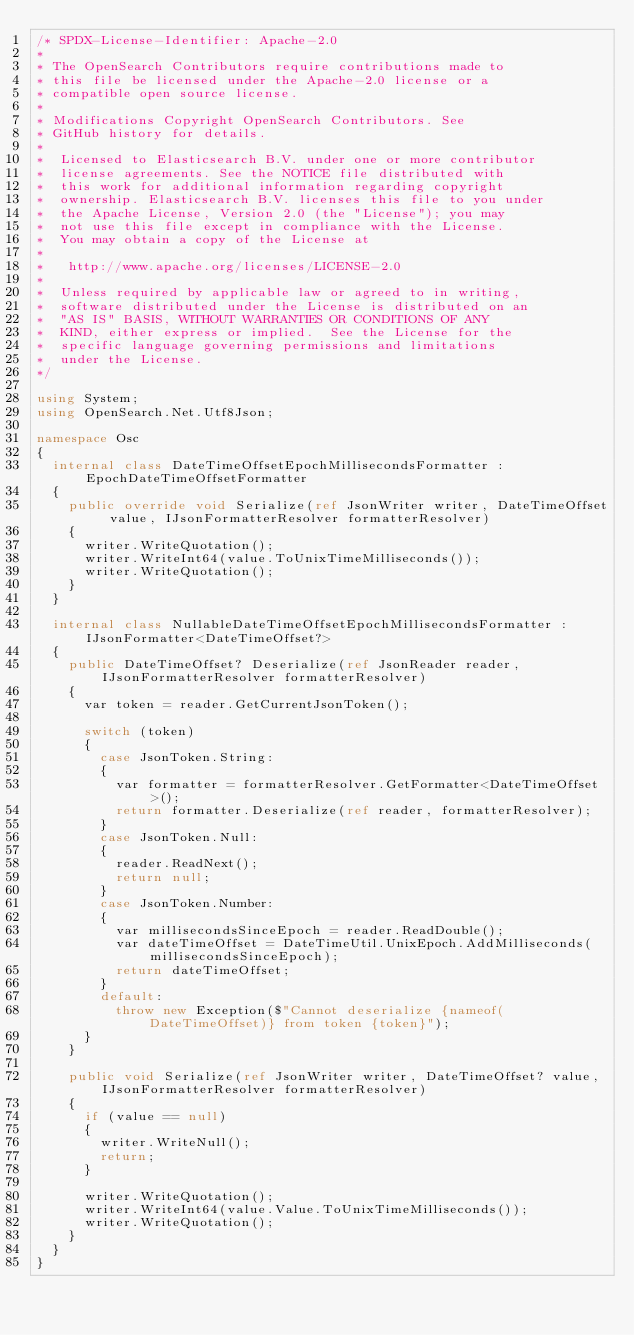Convert code to text. <code><loc_0><loc_0><loc_500><loc_500><_C#_>/* SPDX-License-Identifier: Apache-2.0
*
* The OpenSearch Contributors require contributions made to
* this file be licensed under the Apache-2.0 license or a
* compatible open source license.
*
* Modifications Copyright OpenSearch Contributors. See
* GitHub history for details.
*
*  Licensed to Elasticsearch B.V. under one or more contributor
*  license agreements. See the NOTICE file distributed with
*  this work for additional information regarding copyright
*  ownership. Elasticsearch B.V. licenses this file to you under
*  the Apache License, Version 2.0 (the "License"); you may
*  not use this file except in compliance with the License.
*  You may obtain a copy of the License at
*
* 	http://www.apache.org/licenses/LICENSE-2.0
*
*  Unless required by applicable law or agreed to in writing,
*  software distributed under the License is distributed on an
*  "AS IS" BASIS, WITHOUT WARRANTIES OR CONDITIONS OF ANY
*  KIND, either express or implied.  See the License for the
*  specific language governing permissions and limitations
*  under the License.
*/

using System;
using OpenSearch.Net.Utf8Json;

namespace Osc
{
	internal class DateTimeOffsetEpochMillisecondsFormatter : EpochDateTimeOffsetFormatter
	{
		public override void Serialize(ref JsonWriter writer, DateTimeOffset value, IJsonFormatterResolver formatterResolver)
		{
			writer.WriteQuotation();
			writer.WriteInt64(value.ToUnixTimeMilliseconds());
			writer.WriteQuotation();
		}
	}

	internal class NullableDateTimeOffsetEpochMillisecondsFormatter : IJsonFormatter<DateTimeOffset?>
	{
		public DateTimeOffset? Deserialize(ref JsonReader reader, IJsonFormatterResolver formatterResolver)
		{
			var token = reader.GetCurrentJsonToken();

			switch (token)
			{
				case JsonToken.String:
				{
					var formatter = formatterResolver.GetFormatter<DateTimeOffset>();
					return formatter.Deserialize(ref reader, formatterResolver);
				}
				case JsonToken.Null:
				{
					reader.ReadNext();
					return null;
				}
				case JsonToken.Number:
				{
					var millisecondsSinceEpoch = reader.ReadDouble();
					var dateTimeOffset = DateTimeUtil.UnixEpoch.AddMilliseconds(millisecondsSinceEpoch);
					return dateTimeOffset;
				}
				default:
					throw new Exception($"Cannot deserialize {nameof(DateTimeOffset)} from token {token}");
			}
		}

		public void Serialize(ref JsonWriter writer, DateTimeOffset? value, IJsonFormatterResolver formatterResolver)
		{
			if (value == null)
			{
				writer.WriteNull();
				return;
			}

			writer.WriteQuotation();
			writer.WriteInt64(value.Value.ToUnixTimeMilliseconds());
			writer.WriteQuotation();
		}
	}
}
</code> 